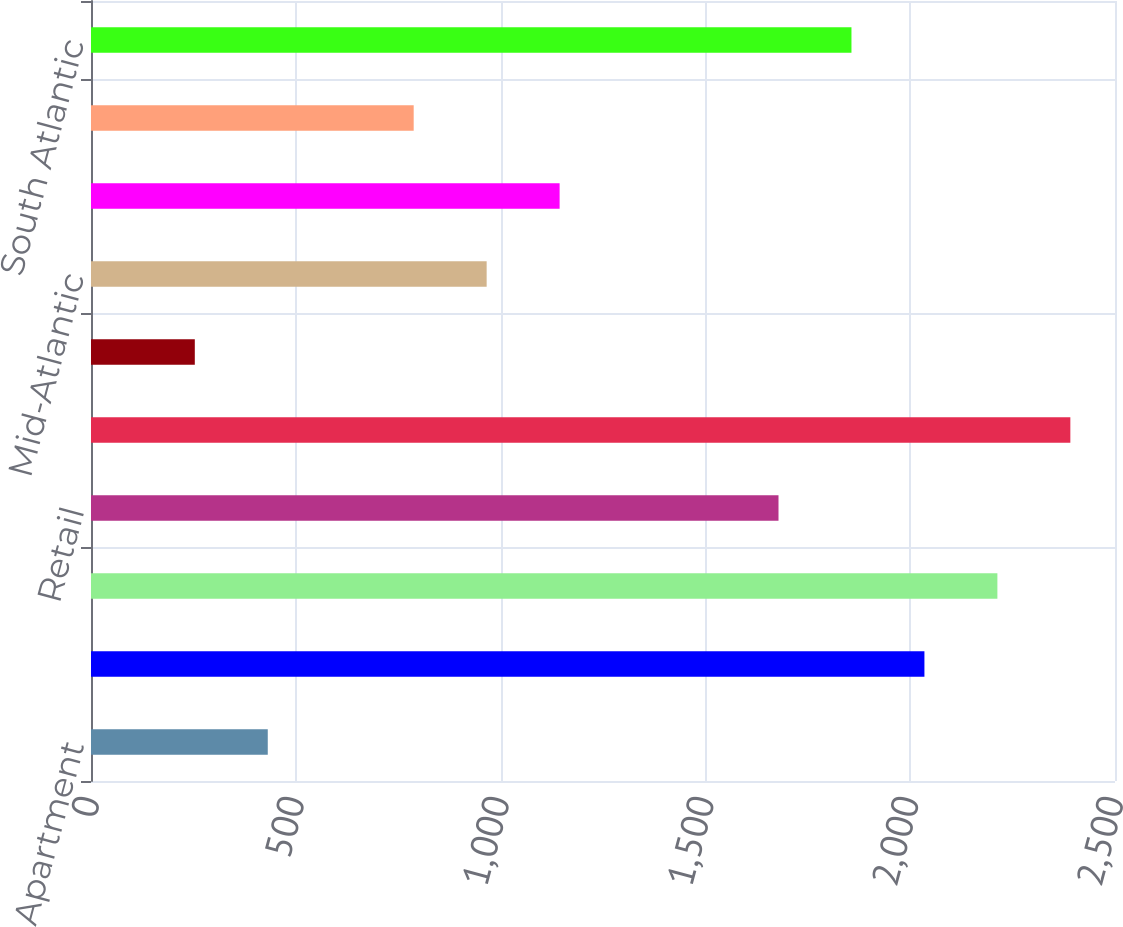<chart> <loc_0><loc_0><loc_500><loc_500><bar_chart><fcel>Apartment<fcel>Industrial<fcel>Office<fcel>Retail<fcel>Total<fcel>New England<fcel>Mid-Atlantic<fcel>East North Central<fcel>West North Central<fcel>South Atlantic<nl><fcel>431.56<fcel>2034.73<fcel>2212.86<fcel>1678.47<fcel>2390.99<fcel>253.43<fcel>965.95<fcel>1144.08<fcel>787.82<fcel>1856.6<nl></chart> 